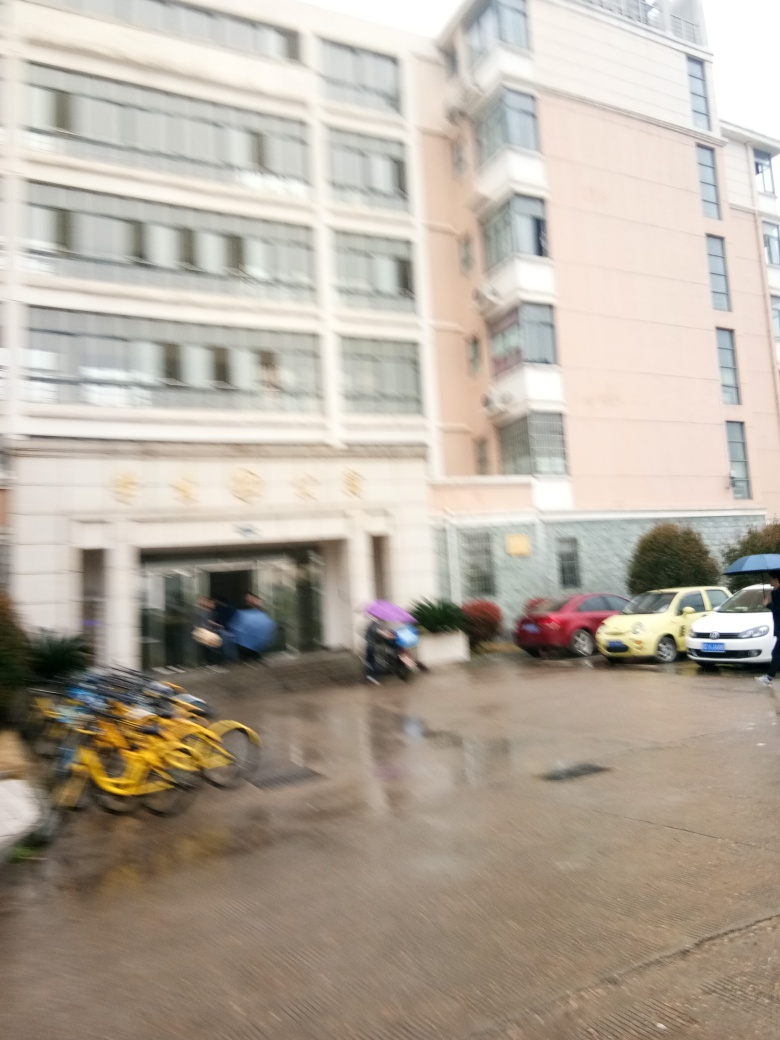Are there texture details lacking in the subject? Regarding the presence of texture details in the subject, it's important to note that the image provided is blurred, which considerably affects the clarity and sharpness of any texture that might be present. Hence, it is difficult to discern finer details, and thus one could argue that there appears to be a lack of texture detail. However, this seems to be primarily the result of the photo's quality rather than the actual subject itself. 